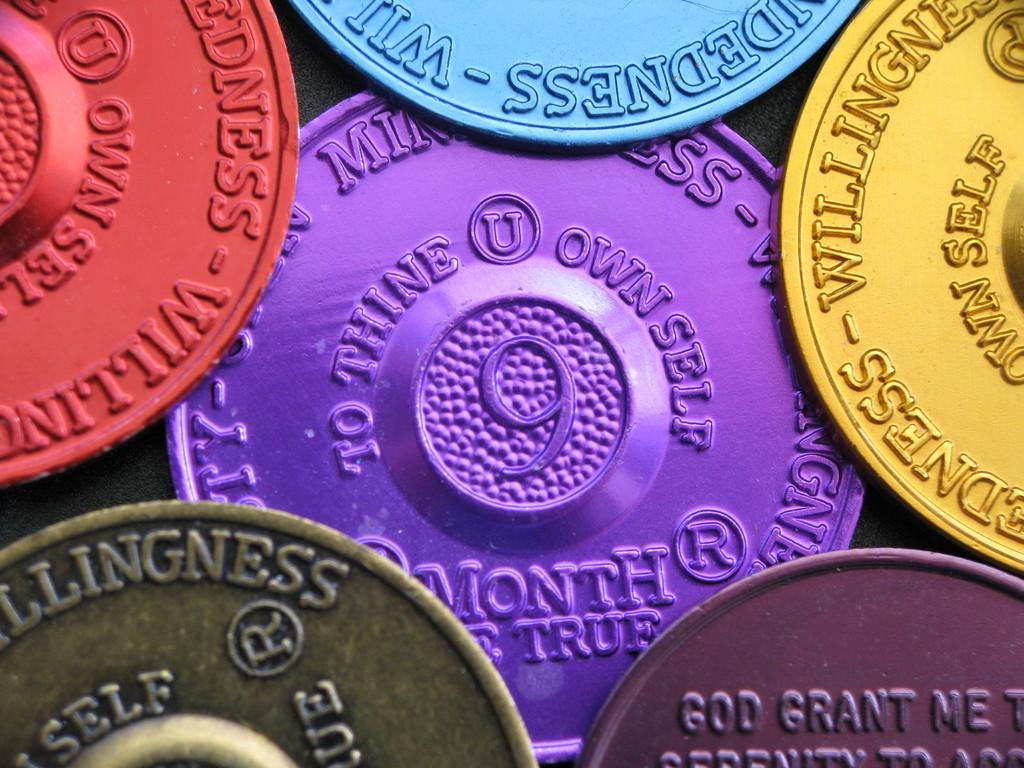<image>
Create a compact narrative representing the image presented. A purple coin surrounded by other colorful coins says "to thine own self" on it. 